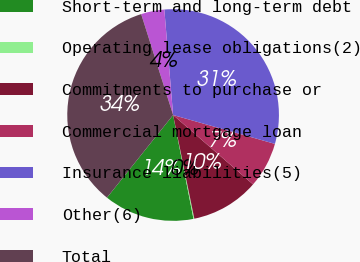Convert chart. <chart><loc_0><loc_0><loc_500><loc_500><pie_chart><fcel>Short-term and long-term debt<fcel>Operating lease obligations(2)<fcel>Commitments to purchase or<fcel>Commercial mortgage loan<fcel>Insurance liabilities(5)<fcel>Other(6)<fcel>Total<nl><fcel>13.83%<fcel>0.13%<fcel>10.41%<fcel>6.98%<fcel>30.72%<fcel>3.56%<fcel>34.38%<nl></chart> 